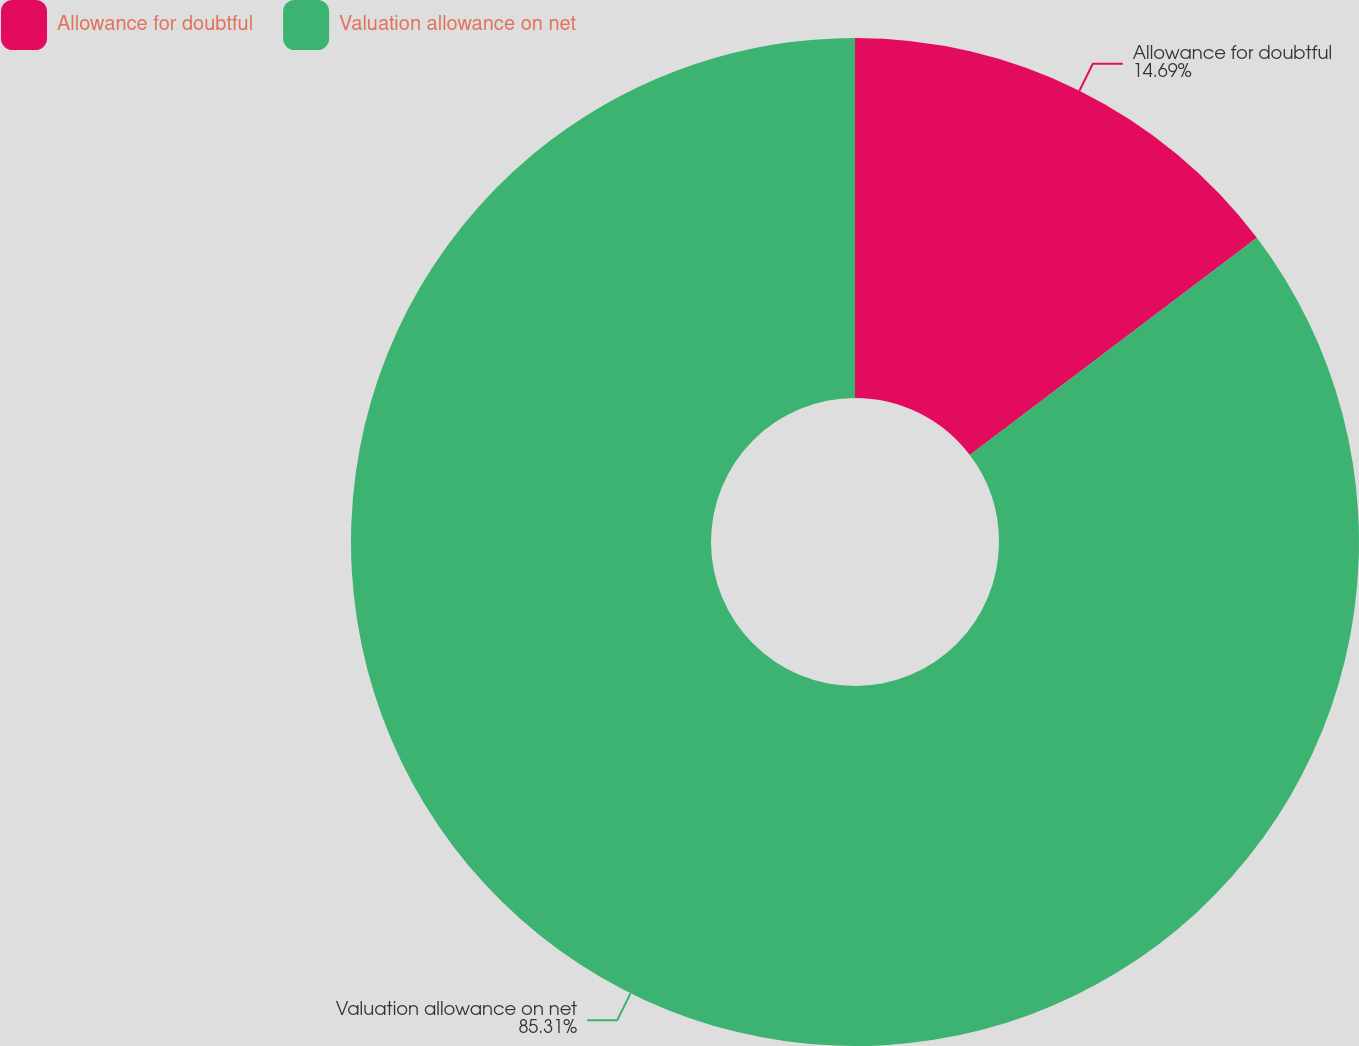Convert chart to OTSL. <chart><loc_0><loc_0><loc_500><loc_500><pie_chart><fcel>Allowance for doubtful<fcel>Valuation allowance on net<nl><fcel>14.69%<fcel>85.31%<nl></chart> 